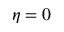Convert formula to latex. <formula><loc_0><loc_0><loc_500><loc_500>\eta = 0</formula> 